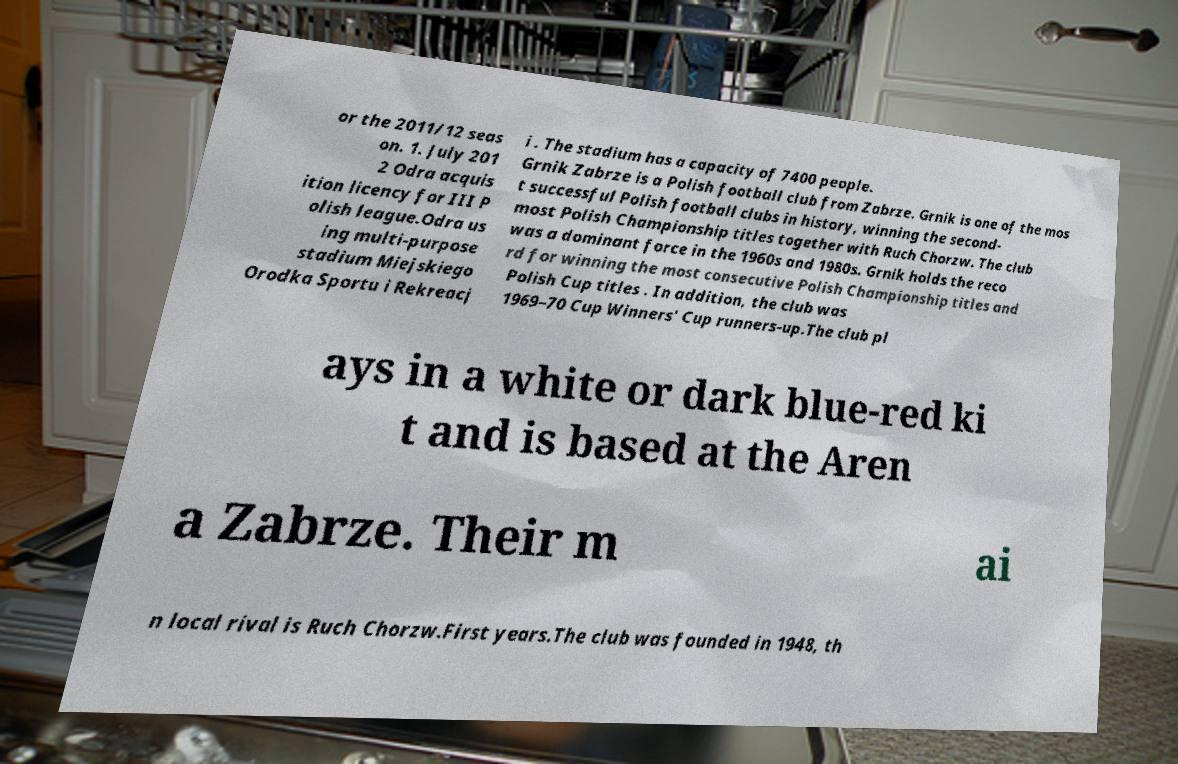What messages or text are displayed in this image? I need them in a readable, typed format. or the 2011/12 seas on. 1. July 201 2 Odra acquis ition licency for III P olish league.Odra us ing multi-purpose stadium Miejskiego Orodka Sportu i Rekreacj i . The stadium has a capacity of 7400 people. Grnik Zabrze is a Polish football club from Zabrze. Grnik is one of the mos t successful Polish football clubs in history, winning the second- most Polish Championship titles together with Ruch Chorzw. The club was a dominant force in the 1960s and 1980s. Grnik holds the reco rd for winning the most consecutive Polish Championship titles and Polish Cup titles . In addition, the club was 1969–70 Cup Winners' Cup runners-up.The club pl ays in a white or dark blue-red ki t and is based at the Aren a Zabrze. Their m ai n local rival is Ruch Chorzw.First years.The club was founded in 1948, th 